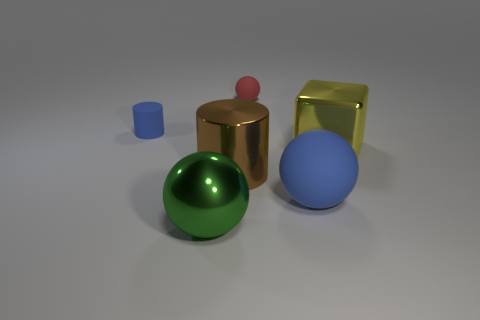Are there fewer big green balls in front of the brown shiny thing than small rubber things right of the big yellow metallic block?
Ensure brevity in your answer.  No. What material is the blue thing that is to the left of the large blue object?
Provide a succinct answer. Rubber. The matte thing that is in front of the tiny red object and on the right side of the blue cylinder is what color?
Offer a terse response. Blue. What number of other things are there of the same color as the large metallic sphere?
Provide a succinct answer. 0. What is the color of the thing that is behind the tiny blue object?
Provide a short and direct response. Red. Is there a yellow metal block that has the same size as the yellow object?
Your answer should be very brief. No. What is the material of the cylinder that is the same size as the red ball?
Offer a terse response. Rubber. What number of things are objects to the right of the small red sphere or small things on the right side of the brown shiny object?
Make the answer very short. 3. Is there a brown thing of the same shape as the big green shiny thing?
Your answer should be very brief. No. What is the material of the object that is the same color as the large matte sphere?
Offer a very short reply. Rubber. 